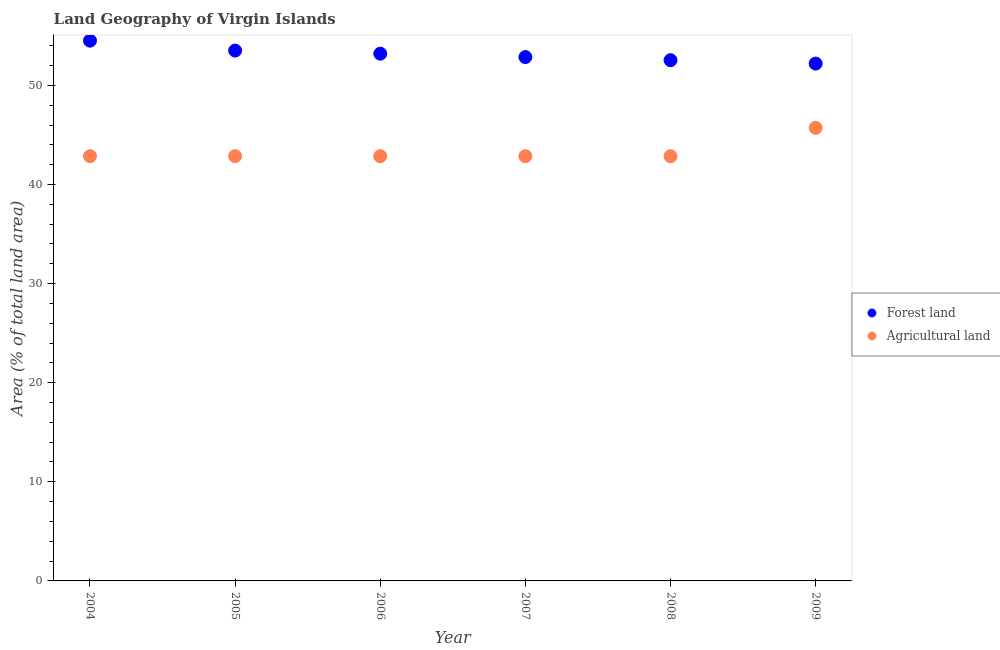How many different coloured dotlines are there?
Provide a succinct answer. 2. What is the percentage of land area under agriculture in 2009?
Your response must be concise. 45.71. Across all years, what is the maximum percentage of land area under agriculture?
Provide a short and direct response. 45.71. Across all years, what is the minimum percentage of land area under agriculture?
Offer a very short reply. 42.86. In which year was the percentage of land area under forests maximum?
Make the answer very short. 2004. What is the total percentage of land area under agriculture in the graph?
Your answer should be compact. 260. What is the difference between the percentage of land area under forests in 2007 and that in 2008?
Keep it short and to the point. 0.31. What is the difference between the percentage of land area under agriculture in 2005 and the percentage of land area under forests in 2004?
Your response must be concise. -11.66. What is the average percentage of land area under forests per year?
Provide a succinct answer. 53.14. In the year 2004, what is the difference between the percentage of land area under forests and percentage of land area under agriculture?
Provide a short and direct response. 11.66. In how many years, is the percentage of land area under agriculture greater than 24 %?
Offer a terse response. 6. What is the ratio of the percentage of land area under agriculture in 2004 to that in 2005?
Your answer should be very brief. 1. Is the percentage of land area under forests in 2006 less than that in 2008?
Keep it short and to the point. No. Is the difference between the percentage of land area under agriculture in 2004 and 2009 greater than the difference between the percentage of land area under forests in 2004 and 2009?
Provide a succinct answer. No. What is the difference between the highest and the second highest percentage of land area under agriculture?
Make the answer very short. 2.86. What is the difference between the highest and the lowest percentage of land area under agriculture?
Your answer should be very brief. 2.86. In how many years, is the percentage of land area under agriculture greater than the average percentage of land area under agriculture taken over all years?
Provide a succinct answer. 1. Is the sum of the percentage of land area under forests in 2004 and 2005 greater than the maximum percentage of land area under agriculture across all years?
Provide a short and direct response. Yes. Does the percentage of land area under forests monotonically increase over the years?
Offer a very short reply. No. How many dotlines are there?
Offer a very short reply. 2. What is the difference between two consecutive major ticks on the Y-axis?
Make the answer very short. 10. Are the values on the major ticks of Y-axis written in scientific E-notation?
Your answer should be very brief. No. How many legend labels are there?
Your answer should be compact. 2. How are the legend labels stacked?
Provide a short and direct response. Vertical. What is the title of the graph?
Offer a terse response. Land Geography of Virgin Islands. What is the label or title of the Y-axis?
Offer a very short reply. Area (% of total land area). What is the Area (% of total land area) in Forest land in 2004?
Your response must be concise. 54.51. What is the Area (% of total land area) in Agricultural land in 2004?
Keep it short and to the point. 42.86. What is the Area (% of total land area) in Forest land in 2005?
Ensure brevity in your answer.  53.51. What is the Area (% of total land area) in Agricultural land in 2005?
Provide a succinct answer. 42.86. What is the Area (% of total land area) of Forest land in 2006?
Offer a terse response. 53.2. What is the Area (% of total land area) of Agricultural land in 2006?
Your answer should be very brief. 42.86. What is the Area (% of total land area) in Forest land in 2007?
Ensure brevity in your answer.  52.86. What is the Area (% of total land area) in Agricultural land in 2007?
Provide a succinct answer. 42.86. What is the Area (% of total land area) of Forest land in 2008?
Provide a short and direct response. 52.54. What is the Area (% of total land area) in Agricultural land in 2008?
Provide a succinct answer. 42.86. What is the Area (% of total land area) of Forest land in 2009?
Offer a terse response. 52.2. What is the Area (% of total land area) of Agricultural land in 2009?
Offer a very short reply. 45.71. Across all years, what is the maximum Area (% of total land area) in Forest land?
Offer a very short reply. 54.51. Across all years, what is the maximum Area (% of total land area) in Agricultural land?
Make the answer very short. 45.71. Across all years, what is the minimum Area (% of total land area) in Forest land?
Offer a terse response. 52.2. Across all years, what is the minimum Area (% of total land area) of Agricultural land?
Your answer should be compact. 42.86. What is the total Area (% of total land area) of Forest land in the graph?
Your response must be concise. 318.83. What is the total Area (% of total land area) of Agricultural land in the graph?
Your answer should be compact. 260. What is the difference between the Area (% of total land area) of Forest land in 2004 and that in 2006?
Offer a very short reply. 1.31. What is the difference between the Area (% of total land area) of Agricultural land in 2004 and that in 2006?
Keep it short and to the point. 0. What is the difference between the Area (% of total land area) in Forest land in 2004 and that in 2007?
Give a very brief answer. 1.66. What is the difference between the Area (% of total land area) of Forest land in 2004 and that in 2008?
Your answer should be compact. 1.97. What is the difference between the Area (% of total land area) in Forest land in 2004 and that in 2009?
Your response must be concise. 2.31. What is the difference between the Area (% of total land area) in Agricultural land in 2004 and that in 2009?
Your answer should be compact. -2.86. What is the difference between the Area (% of total land area) of Forest land in 2005 and that in 2006?
Your answer should be compact. 0.31. What is the difference between the Area (% of total land area) in Agricultural land in 2005 and that in 2006?
Your answer should be compact. 0. What is the difference between the Area (% of total land area) of Forest land in 2005 and that in 2007?
Your answer should be very brief. 0.66. What is the difference between the Area (% of total land area) in Forest land in 2005 and that in 2008?
Your response must be concise. 0.97. What is the difference between the Area (% of total land area) in Forest land in 2005 and that in 2009?
Give a very brief answer. 1.31. What is the difference between the Area (% of total land area) of Agricultural land in 2005 and that in 2009?
Provide a short and direct response. -2.86. What is the difference between the Area (% of total land area) in Forest land in 2006 and that in 2007?
Provide a succinct answer. 0.34. What is the difference between the Area (% of total land area) in Forest land in 2006 and that in 2008?
Give a very brief answer. 0.66. What is the difference between the Area (% of total land area) in Agricultural land in 2006 and that in 2009?
Your response must be concise. -2.86. What is the difference between the Area (% of total land area) of Forest land in 2007 and that in 2008?
Ensure brevity in your answer.  0.31. What is the difference between the Area (% of total land area) of Agricultural land in 2007 and that in 2008?
Provide a short and direct response. 0. What is the difference between the Area (% of total land area) of Forest land in 2007 and that in 2009?
Keep it short and to the point. 0.66. What is the difference between the Area (% of total land area) of Agricultural land in 2007 and that in 2009?
Ensure brevity in your answer.  -2.86. What is the difference between the Area (% of total land area) of Forest land in 2008 and that in 2009?
Offer a very short reply. 0.34. What is the difference between the Area (% of total land area) of Agricultural land in 2008 and that in 2009?
Offer a terse response. -2.86. What is the difference between the Area (% of total land area) of Forest land in 2004 and the Area (% of total land area) of Agricultural land in 2005?
Your answer should be very brief. 11.66. What is the difference between the Area (% of total land area) of Forest land in 2004 and the Area (% of total land area) of Agricultural land in 2006?
Make the answer very short. 11.66. What is the difference between the Area (% of total land area) of Forest land in 2004 and the Area (% of total land area) of Agricultural land in 2007?
Give a very brief answer. 11.66. What is the difference between the Area (% of total land area) of Forest land in 2004 and the Area (% of total land area) of Agricultural land in 2008?
Make the answer very short. 11.66. What is the difference between the Area (% of total land area) in Forest land in 2005 and the Area (% of total land area) in Agricultural land in 2006?
Keep it short and to the point. 10.66. What is the difference between the Area (% of total land area) of Forest land in 2005 and the Area (% of total land area) of Agricultural land in 2007?
Offer a terse response. 10.66. What is the difference between the Area (% of total land area) in Forest land in 2005 and the Area (% of total land area) in Agricultural land in 2008?
Offer a terse response. 10.66. What is the difference between the Area (% of total land area) of Forest land in 2005 and the Area (% of total land area) of Agricultural land in 2009?
Provide a short and direct response. 7.8. What is the difference between the Area (% of total land area) of Forest land in 2006 and the Area (% of total land area) of Agricultural land in 2007?
Offer a very short reply. 10.34. What is the difference between the Area (% of total land area) in Forest land in 2006 and the Area (% of total land area) in Agricultural land in 2008?
Offer a terse response. 10.34. What is the difference between the Area (% of total land area) of Forest land in 2006 and the Area (% of total land area) of Agricultural land in 2009?
Make the answer very short. 7.49. What is the difference between the Area (% of total land area) of Forest land in 2007 and the Area (% of total land area) of Agricultural land in 2009?
Give a very brief answer. 7.14. What is the difference between the Area (% of total land area) in Forest land in 2008 and the Area (% of total land area) in Agricultural land in 2009?
Provide a short and direct response. 6.83. What is the average Area (% of total land area) of Forest land per year?
Offer a very short reply. 53.14. What is the average Area (% of total land area) of Agricultural land per year?
Provide a succinct answer. 43.33. In the year 2004, what is the difference between the Area (% of total land area) in Forest land and Area (% of total land area) in Agricultural land?
Provide a short and direct response. 11.66. In the year 2005, what is the difference between the Area (% of total land area) in Forest land and Area (% of total land area) in Agricultural land?
Offer a terse response. 10.66. In the year 2006, what is the difference between the Area (% of total land area) of Forest land and Area (% of total land area) of Agricultural land?
Make the answer very short. 10.34. In the year 2008, what is the difference between the Area (% of total land area) in Forest land and Area (% of total land area) in Agricultural land?
Your answer should be very brief. 9.69. In the year 2009, what is the difference between the Area (% of total land area) of Forest land and Area (% of total land area) of Agricultural land?
Ensure brevity in your answer.  6.49. What is the ratio of the Area (% of total land area) of Forest land in 2004 to that in 2005?
Provide a short and direct response. 1.02. What is the ratio of the Area (% of total land area) in Forest land in 2004 to that in 2006?
Provide a succinct answer. 1.02. What is the ratio of the Area (% of total land area) in Forest land in 2004 to that in 2007?
Provide a succinct answer. 1.03. What is the ratio of the Area (% of total land area) of Agricultural land in 2004 to that in 2007?
Provide a succinct answer. 1. What is the ratio of the Area (% of total land area) of Forest land in 2004 to that in 2008?
Provide a short and direct response. 1.04. What is the ratio of the Area (% of total land area) in Agricultural land in 2004 to that in 2008?
Make the answer very short. 1. What is the ratio of the Area (% of total land area) of Forest land in 2004 to that in 2009?
Ensure brevity in your answer.  1.04. What is the ratio of the Area (% of total land area) of Forest land in 2005 to that in 2006?
Provide a short and direct response. 1.01. What is the ratio of the Area (% of total land area) in Agricultural land in 2005 to that in 2006?
Your response must be concise. 1. What is the ratio of the Area (% of total land area) in Forest land in 2005 to that in 2007?
Make the answer very short. 1.01. What is the ratio of the Area (% of total land area) of Agricultural land in 2005 to that in 2007?
Your answer should be compact. 1. What is the ratio of the Area (% of total land area) of Forest land in 2005 to that in 2008?
Keep it short and to the point. 1.02. What is the ratio of the Area (% of total land area) of Forest land in 2005 to that in 2009?
Ensure brevity in your answer.  1.03. What is the ratio of the Area (% of total land area) in Agricultural land in 2006 to that in 2007?
Give a very brief answer. 1. What is the ratio of the Area (% of total land area) of Forest land in 2006 to that in 2008?
Keep it short and to the point. 1.01. What is the ratio of the Area (% of total land area) of Forest land in 2006 to that in 2009?
Ensure brevity in your answer.  1.02. What is the ratio of the Area (% of total land area) of Agricultural land in 2007 to that in 2008?
Your answer should be compact. 1. What is the ratio of the Area (% of total land area) of Forest land in 2007 to that in 2009?
Provide a short and direct response. 1.01. What is the ratio of the Area (% of total land area) in Agricultural land in 2007 to that in 2009?
Provide a short and direct response. 0.94. What is the ratio of the Area (% of total land area) in Forest land in 2008 to that in 2009?
Offer a terse response. 1.01. What is the ratio of the Area (% of total land area) in Agricultural land in 2008 to that in 2009?
Your answer should be very brief. 0.94. What is the difference between the highest and the second highest Area (% of total land area) of Agricultural land?
Keep it short and to the point. 2.86. What is the difference between the highest and the lowest Area (% of total land area) of Forest land?
Your answer should be very brief. 2.31. What is the difference between the highest and the lowest Area (% of total land area) in Agricultural land?
Make the answer very short. 2.86. 